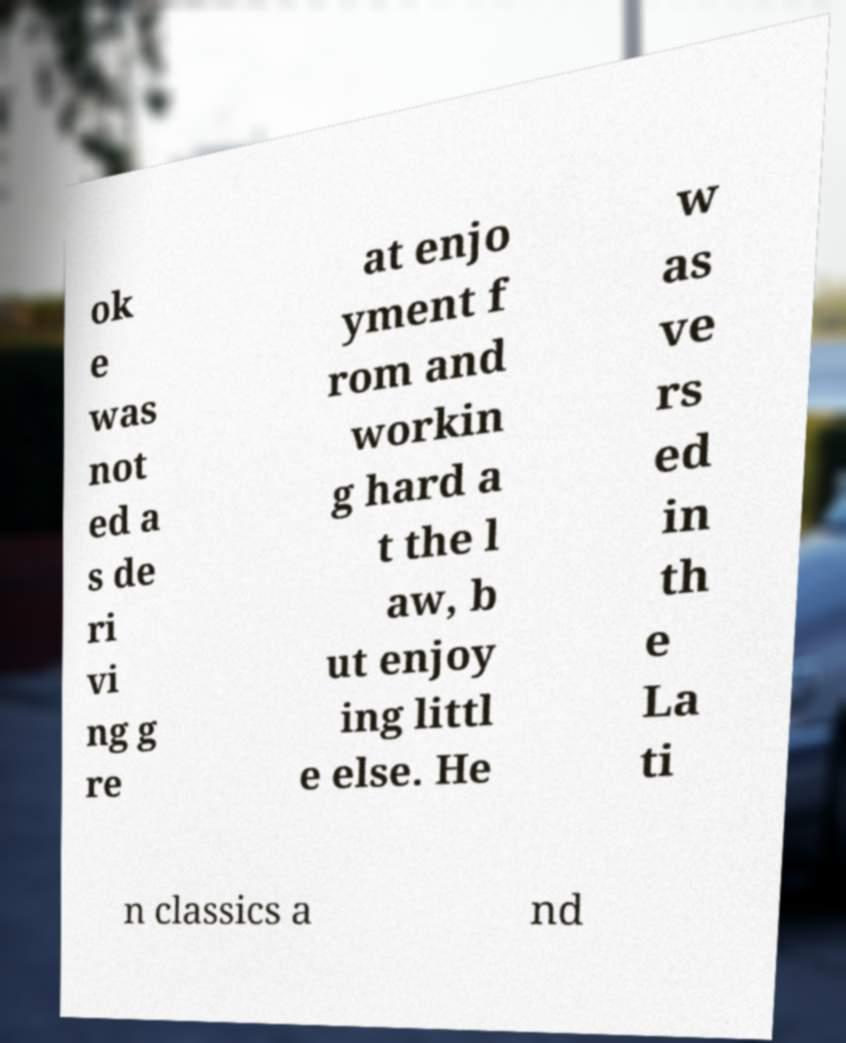Could you extract and type out the text from this image? ok e was not ed a s de ri vi ng g re at enjo yment f rom and workin g hard a t the l aw, b ut enjoy ing littl e else. He w as ve rs ed in th e La ti n classics a nd 